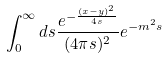<formula> <loc_0><loc_0><loc_500><loc_500>\int _ { 0 } ^ { \infty } d s \frac { e ^ { - \frac { ( x - y ) ^ { 2 } } { 4 s } } } { ( 4 \pi s ) ^ { 2 } } e ^ { - m ^ { 2 } s }</formula> 